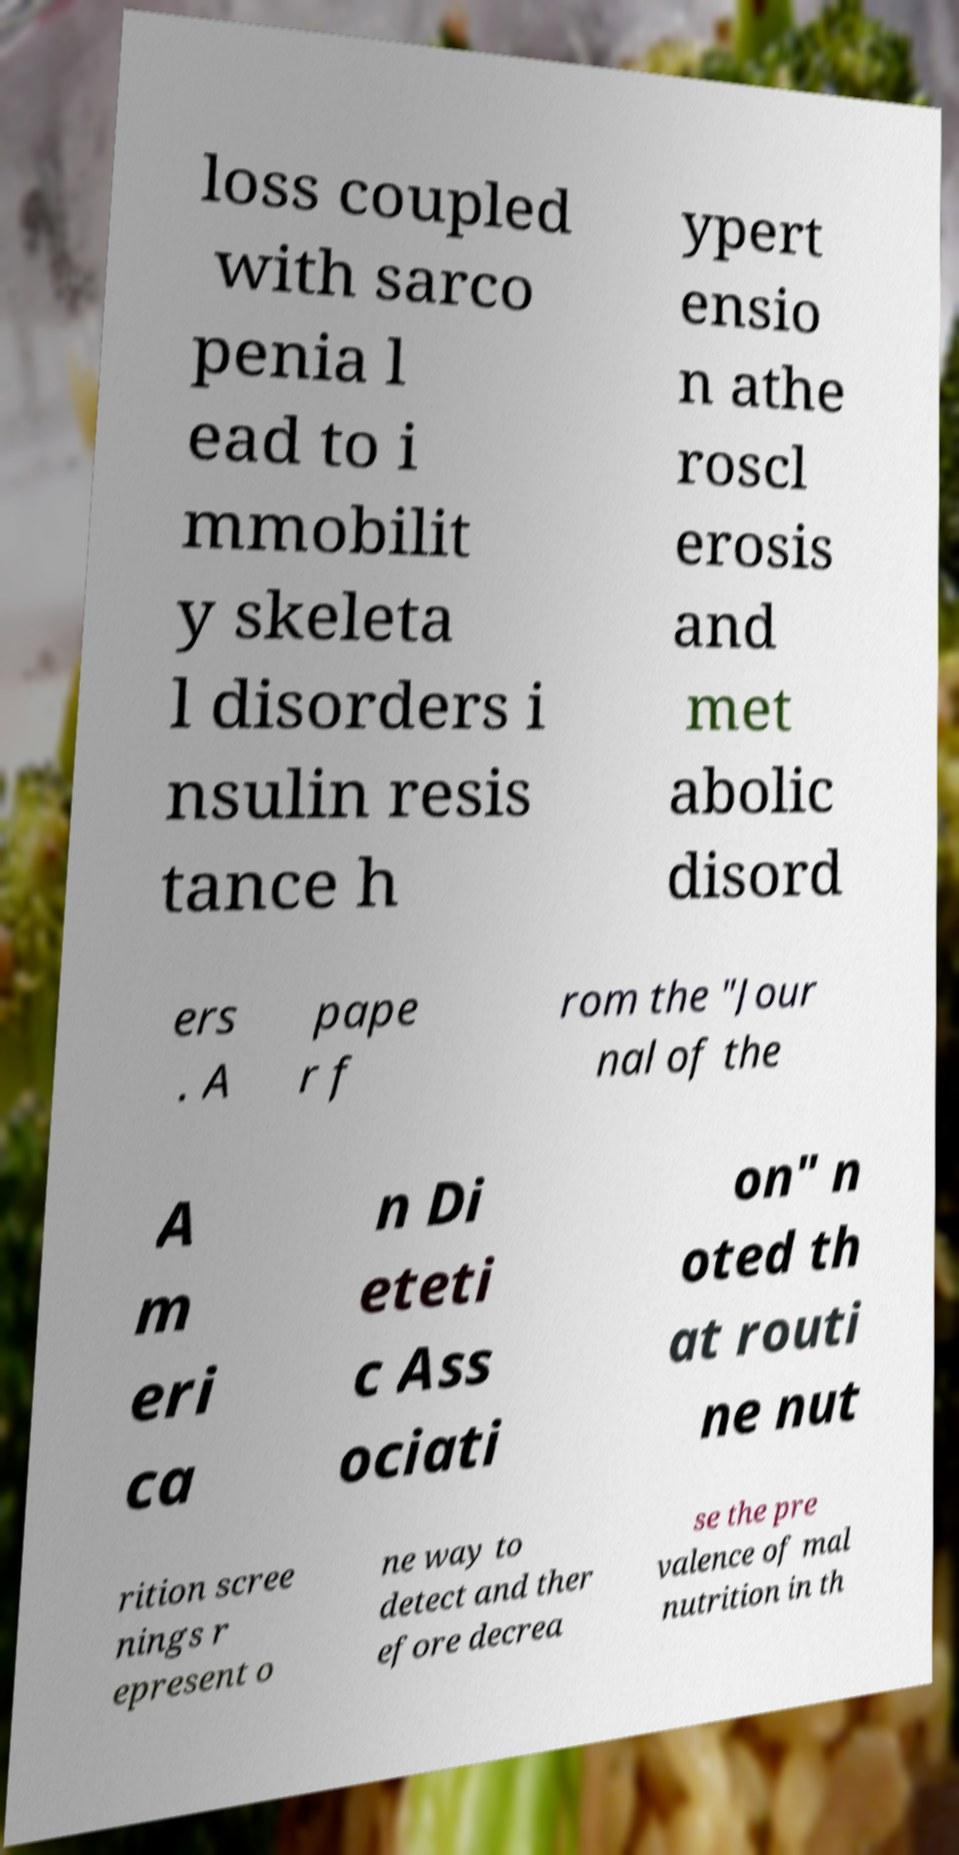What messages or text are displayed in this image? I need them in a readable, typed format. loss coupled with sarco penia l ead to i mmobilit y skeleta l disorders i nsulin resis tance h ypert ensio n athe roscl erosis and met abolic disord ers . A pape r f rom the "Jour nal of the A m eri ca n Di eteti c Ass ociati on" n oted th at routi ne nut rition scree nings r epresent o ne way to detect and ther efore decrea se the pre valence of mal nutrition in th 